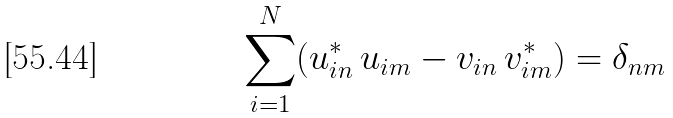Convert formula to latex. <formula><loc_0><loc_0><loc_500><loc_500>\sum _ { i = 1 } ^ { N } ( u _ { i n } ^ { \ast } \, u _ { i m } - v _ { i n } \, v _ { i m } ^ { \ast } ) = \delta _ { n m }</formula> 